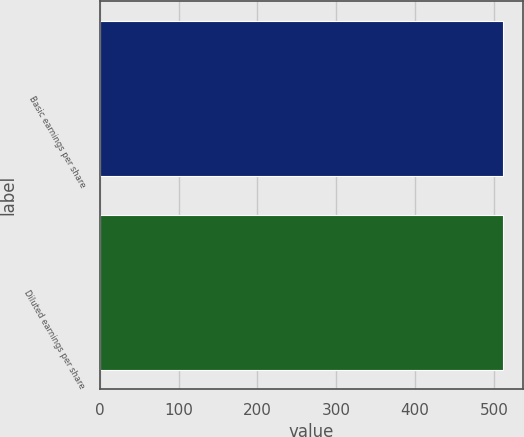<chart> <loc_0><loc_0><loc_500><loc_500><bar_chart><fcel>Basic earnings per share<fcel>Diluted earnings per share<nl><fcel>511.2<fcel>511.3<nl></chart> 